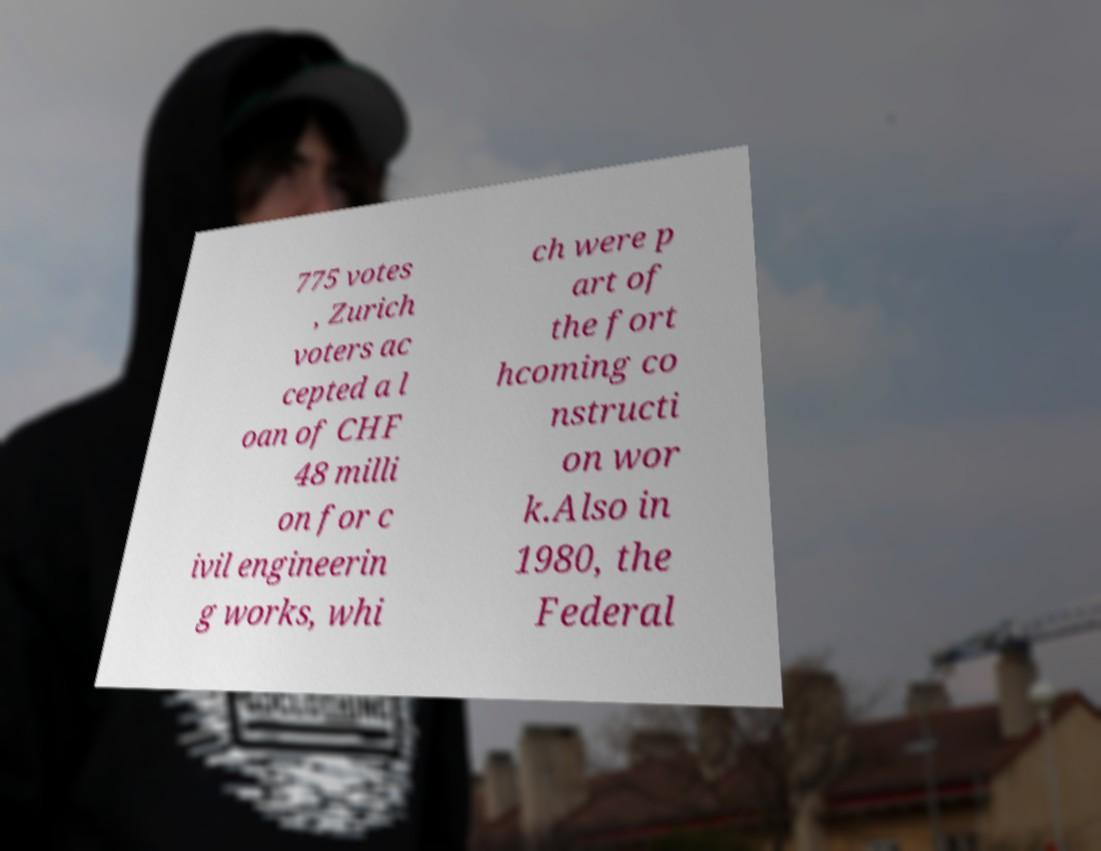For documentation purposes, I need the text within this image transcribed. Could you provide that? 775 votes , Zurich voters ac cepted a l oan of CHF 48 milli on for c ivil engineerin g works, whi ch were p art of the fort hcoming co nstructi on wor k.Also in 1980, the Federal 